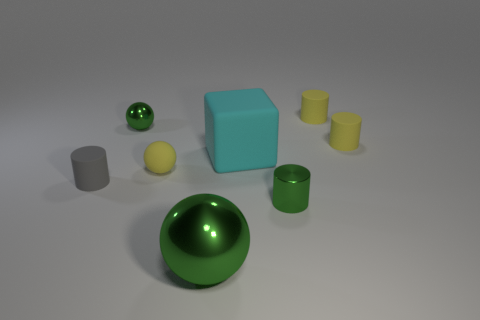What is the size of the cyan object that is made of the same material as the tiny gray cylinder?
Provide a short and direct response. Large. Do the yellow matte object that is on the left side of the cyan matte thing and the green thing to the left of the big metallic ball have the same shape?
Provide a succinct answer. Yes. What is the color of the big block that is made of the same material as the gray cylinder?
Give a very brief answer. Cyan. There is a green metallic thing that is in front of the green cylinder; is its size the same as the yellow rubber cylinder that is behind the tiny metal ball?
Offer a terse response. No. There is a tiny thing that is both in front of the big matte cube and on the right side of the big green metal sphere; what shape is it?
Ensure brevity in your answer.  Cylinder. Are there any tiny purple blocks that have the same material as the tiny gray cylinder?
Provide a short and direct response. No. There is a tiny sphere that is the same color as the shiny cylinder; what material is it?
Make the answer very short. Metal. Are the small green thing that is in front of the small gray matte object and the large thing in front of the tiny gray rubber cylinder made of the same material?
Offer a very short reply. Yes. Are there more big cubes than small blue rubber spheres?
Keep it short and to the point. Yes. What is the color of the tiny matte cylinder on the left side of the small green metal thing in front of the tiny green thing to the left of the tiny yellow ball?
Your response must be concise. Gray. 